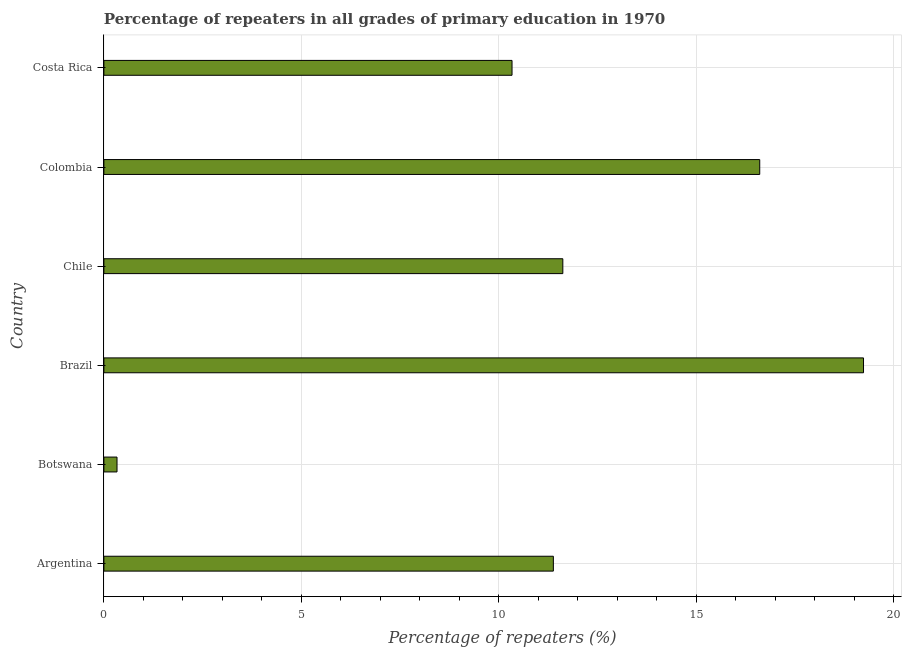Does the graph contain any zero values?
Keep it short and to the point. No. What is the title of the graph?
Offer a terse response. Percentage of repeaters in all grades of primary education in 1970. What is the label or title of the X-axis?
Keep it short and to the point. Percentage of repeaters (%). What is the label or title of the Y-axis?
Offer a very short reply. Country. What is the percentage of repeaters in primary education in Brazil?
Keep it short and to the point. 19.24. Across all countries, what is the maximum percentage of repeaters in primary education?
Your answer should be very brief. 19.24. Across all countries, what is the minimum percentage of repeaters in primary education?
Keep it short and to the point. 0.33. In which country was the percentage of repeaters in primary education maximum?
Offer a terse response. Brazil. In which country was the percentage of repeaters in primary education minimum?
Your answer should be compact. Botswana. What is the sum of the percentage of repeaters in primary education?
Offer a very short reply. 69.53. What is the difference between the percentage of repeaters in primary education in Botswana and Brazil?
Make the answer very short. -18.91. What is the average percentage of repeaters in primary education per country?
Provide a succinct answer. 11.59. What is the median percentage of repeaters in primary education?
Offer a very short reply. 11.5. What is the ratio of the percentage of repeaters in primary education in Brazil to that in Chile?
Your response must be concise. 1.66. Is the difference between the percentage of repeaters in primary education in Argentina and Chile greater than the difference between any two countries?
Give a very brief answer. No. What is the difference between the highest and the second highest percentage of repeaters in primary education?
Keep it short and to the point. 2.63. What is the difference between the highest and the lowest percentage of repeaters in primary education?
Your answer should be compact. 18.91. In how many countries, is the percentage of repeaters in primary education greater than the average percentage of repeaters in primary education taken over all countries?
Make the answer very short. 3. Are all the bars in the graph horizontal?
Keep it short and to the point. Yes. What is the Percentage of repeaters (%) in Argentina?
Your answer should be compact. 11.38. What is the Percentage of repeaters (%) of Botswana?
Keep it short and to the point. 0.33. What is the Percentage of repeaters (%) in Brazil?
Ensure brevity in your answer.  19.24. What is the Percentage of repeaters (%) in Chile?
Your response must be concise. 11.62. What is the Percentage of repeaters (%) in Colombia?
Your answer should be very brief. 16.61. What is the Percentage of repeaters (%) of Costa Rica?
Your answer should be compact. 10.34. What is the difference between the Percentage of repeaters (%) in Argentina and Botswana?
Your answer should be very brief. 11.05. What is the difference between the Percentage of repeaters (%) in Argentina and Brazil?
Ensure brevity in your answer.  -7.86. What is the difference between the Percentage of repeaters (%) in Argentina and Chile?
Offer a terse response. -0.24. What is the difference between the Percentage of repeaters (%) in Argentina and Colombia?
Your answer should be very brief. -5.23. What is the difference between the Percentage of repeaters (%) in Argentina and Costa Rica?
Ensure brevity in your answer.  1.05. What is the difference between the Percentage of repeaters (%) in Botswana and Brazil?
Your response must be concise. -18.91. What is the difference between the Percentage of repeaters (%) in Botswana and Chile?
Offer a very short reply. -11.29. What is the difference between the Percentage of repeaters (%) in Botswana and Colombia?
Make the answer very short. -16.28. What is the difference between the Percentage of repeaters (%) in Botswana and Costa Rica?
Ensure brevity in your answer.  -10.01. What is the difference between the Percentage of repeaters (%) in Brazil and Chile?
Your answer should be very brief. 7.62. What is the difference between the Percentage of repeaters (%) in Brazil and Colombia?
Ensure brevity in your answer.  2.63. What is the difference between the Percentage of repeaters (%) in Brazil and Costa Rica?
Provide a succinct answer. 8.9. What is the difference between the Percentage of repeaters (%) in Chile and Colombia?
Offer a very short reply. -4.99. What is the difference between the Percentage of repeaters (%) in Chile and Costa Rica?
Provide a short and direct response. 1.29. What is the difference between the Percentage of repeaters (%) in Colombia and Costa Rica?
Provide a short and direct response. 6.27. What is the ratio of the Percentage of repeaters (%) in Argentina to that in Botswana?
Ensure brevity in your answer.  34.24. What is the ratio of the Percentage of repeaters (%) in Argentina to that in Brazil?
Provide a short and direct response. 0.59. What is the ratio of the Percentage of repeaters (%) in Argentina to that in Chile?
Offer a terse response. 0.98. What is the ratio of the Percentage of repeaters (%) in Argentina to that in Colombia?
Ensure brevity in your answer.  0.69. What is the ratio of the Percentage of repeaters (%) in Argentina to that in Costa Rica?
Offer a very short reply. 1.1. What is the ratio of the Percentage of repeaters (%) in Botswana to that in Brazil?
Offer a terse response. 0.02. What is the ratio of the Percentage of repeaters (%) in Botswana to that in Chile?
Your response must be concise. 0.03. What is the ratio of the Percentage of repeaters (%) in Botswana to that in Colombia?
Make the answer very short. 0.02. What is the ratio of the Percentage of repeaters (%) in Botswana to that in Costa Rica?
Ensure brevity in your answer.  0.03. What is the ratio of the Percentage of repeaters (%) in Brazil to that in Chile?
Make the answer very short. 1.66. What is the ratio of the Percentage of repeaters (%) in Brazil to that in Colombia?
Give a very brief answer. 1.16. What is the ratio of the Percentage of repeaters (%) in Brazil to that in Costa Rica?
Your answer should be compact. 1.86. What is the ratio of the Percentage of repeaters (%) in Chile to that in Costa Rica?
Provide a short and direct response. 1.12. What is the ratio of the Percentage of repeaters (%) in Colombia to that in Costa Rica?
Your answer should be compact. 1.61. 